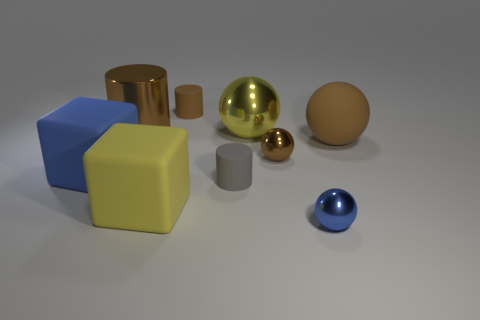Subtract all purple blocks. How many brown cylinders are left? 2 Subtract 1 balls. How many balls are left? 3 Subtract all brown metal balls. How many balls are left? 3 Subtract all blue spheres. How many spheres are left? 3 Add 1 tiny gray spheres. How many objects exist? 10 Subtract all blocks. How many objects are left? 7 Subtract all gray balls. Subtract all yellow cylinders. How many balls are left? 4 Subtract 0 red spheres. How many objects are left? 9 Subtract all big brown rubber things. Subtract all cubes. How many objects are left? 6 Add 9 gray cylinders. How many gray cylinders are left? 10 